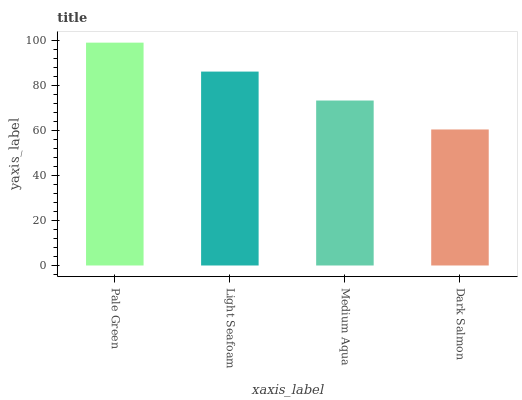Is Light Seafoam the minimum?
Answer yes or no. No. Is Light Seafoam the maximum?
Answer yes or no. No. Is Pale Green greater than Light Seafoam?
Answer yes or no. Yes. Is Light Seafoam less than Pale Green?
Answer yes or no. Yes. Is Light Seafoam greater than Pale Green?
Answer yes or no. No. Is Pale Green less than Light Seafoam?
Answer yes or no. No. Is Light Seafoam the high median?
Answer yes or no. Yes. Is Medium Aqua the low median?
Answer yes or no. Yes. Is Pale Green the high median?
Answer yes or no. No. Is Light Seafoam the low median?
Answer yes or no. No. 